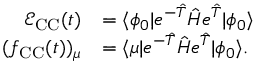Convert formula to latex. <formula><loc_0><loc_0><loc_500><loc_500>\begin{array} { r l } { \mathcal { E } _ { C C } ( t ) } & { = \langle \phi _ { 0 } | e ^ { - \hat { T } } \hat { H } e ^ { \hat { T } } | \phi _ { 0 } \rangle } \\ { ( f _ { C C } ( t ) ) _ { \mu } } & { = \langle \mu | e ^ { - \hat { T } } \hat { H } e ^ { \hat { T } } | \phi _ { 0 } \rangle . } \end{array}</formula> 